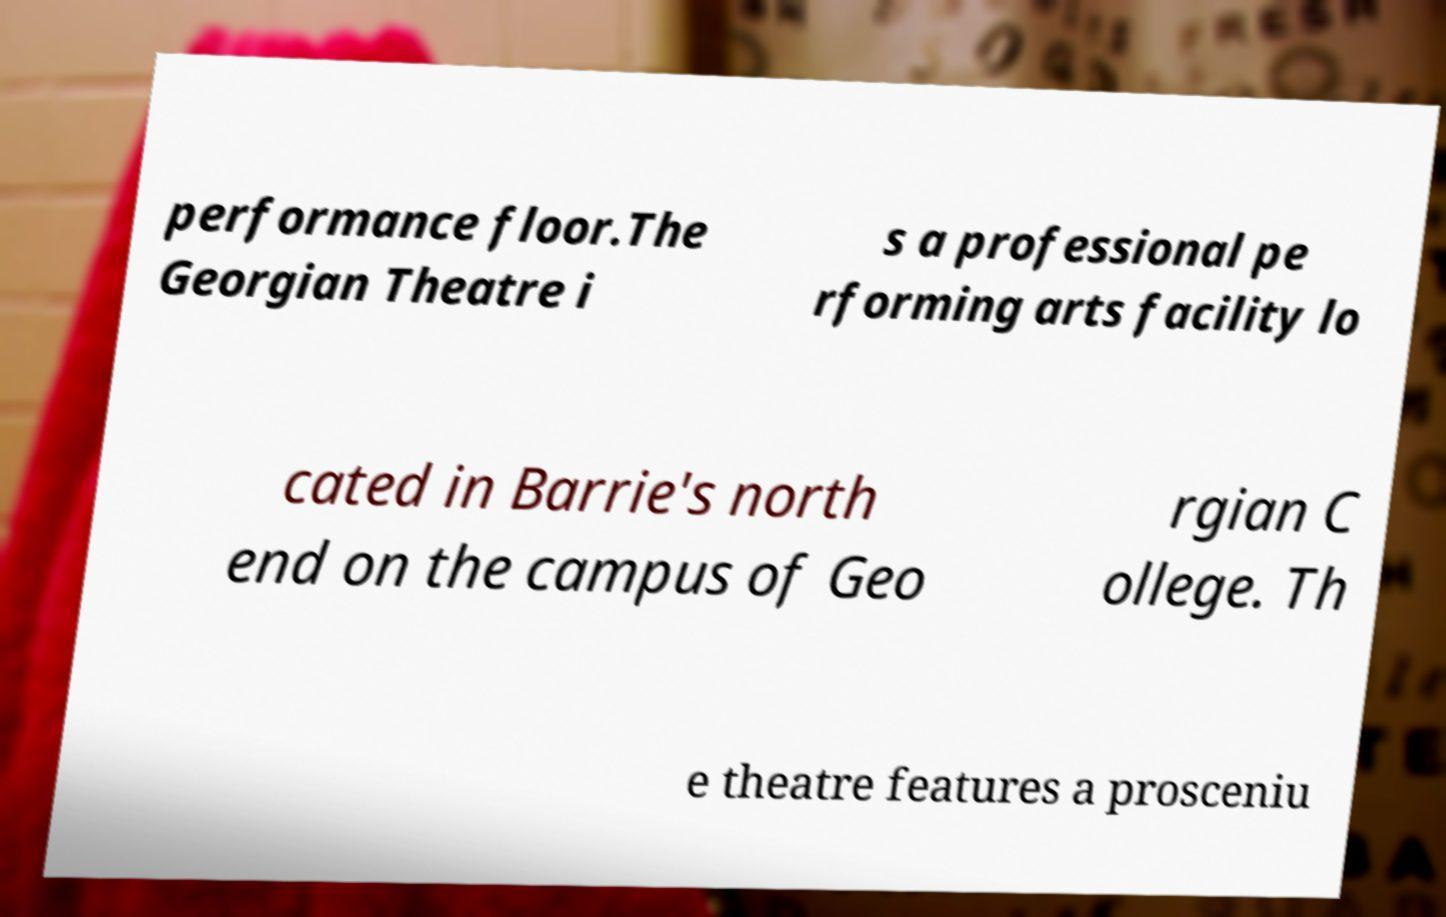What messages or text are displayed in this image? I need them in a readable, typed format. performance floor.The Georgian Theatre i s a professional pe rforming arts facility lo cated in Barrie's north end on the campus of Geo rgian C ollege. Th e theatre features a prosceniu 